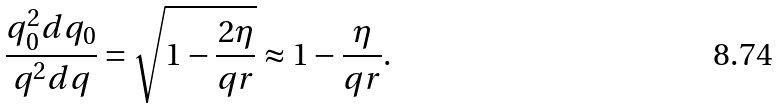Convert formula to latex. <formula><loc_0><loc_0><loc_500><loc_500>\frac { q _ { 0 } ^ { 2 } d q _ { 0 } } { q ^ { 2 } d q } = \sqrt { 1 - \frac { 2 \eta } { q r } } \approx 1 - \frac { \eta } { q r } .</formula> 